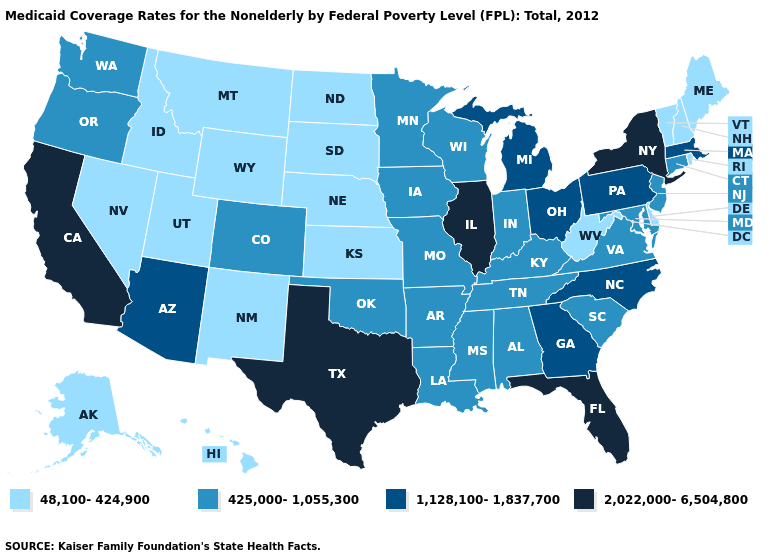Does Oregon have the highest value in the West?
Concise answer only. No. Does the map have missing data?
Concise answer only. No. What is the lowest value in states that border Nebraska?
Concise answer only. 48,100-424,900. Which states have the lowest value in the USA?
Give a very brief answer. Alaska, Delaware, Hawaii, Idaho, Kansas, Maine, Montana, Nebraska, Nevada, New Hampshire, New Mexico, North Dakota, Rhode Island, South Dakota, Utah, Vermont, West Virginia, Wyoming. Name the states that have a value in the range 1,128,100-1,837,700?
Be succinct. Arizona, Georgia, Massachusetts, Michigan, North Carolina, Ohio, Pennsylvania. What is the highest value in the South ?
Quick response, please. 2,022,000-6,504,800. Does North Dakota have the lowest value in the MidWest?
Short answer required. Yes. What is the value of Massachusetts?
Quick response, please. 1,128,100-1,837,700. What is the highest value in the Northeast ?
Answer briefly. 2,022,000-6,504,800. Does Texas have the highest value in the USA?
Be succinct. Yes. Name the states that have a value in the range 2,022,000-6,504,800?
Keep it brief. California, Florida, Illinois, New York, Texas. What is the highest value in the West ?
Short answer required. 2,022,000-6,504,800. Name the states that have a value in the range 2,022,000-6,504,800?
Write a very short answer. California, Florida, Illinois, New York, Texas. Does Rhode Island have a lower value than Maryland?
Quick response, please. Yes. What is the highest value in the USA?
Write a very short answer. 2,022,000-6,504,800. 